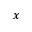<formula> <loc_0><loc_0><loc_500><loc_500>x</formula> 